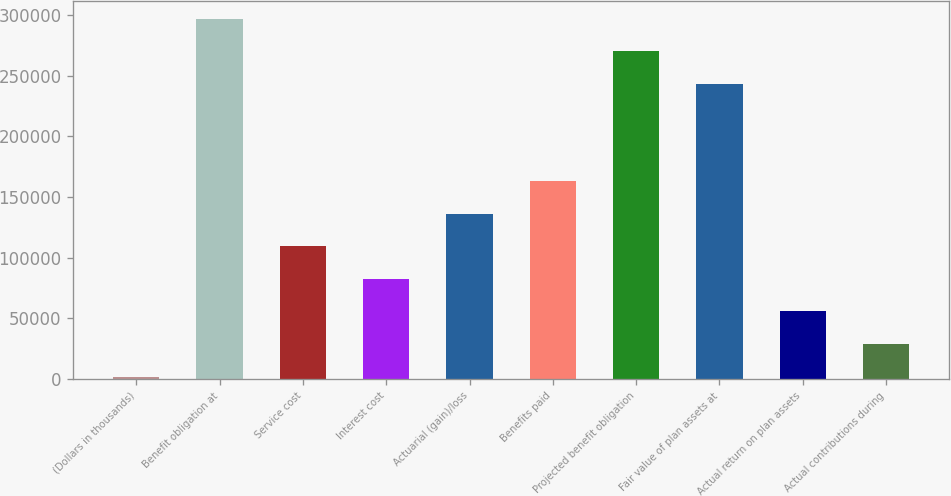Convert chart to OTSL. <chart><loc_0><loc_0><loc_500><loc_500><bar_chart><fcel>(Dollars in thousands)<fcel>Benefit obligation at<fcel>Service cost<fcel>Interest cost<fcel>Actuarial (gain)/loss<fcel>Benefits paid<fcel>Projected benefit obligation<fcel>Fair value of plan assets at<fcel>Actual return on plan assets<fcel>Actual contributions during<nl><fcel>2015<fcel>296870<fcel>109235<fcel>82430<fcel>136040<fcel>162845<fcel>270065<fcel>243260<fcel>55625<fcel>28820<nl></chart> 